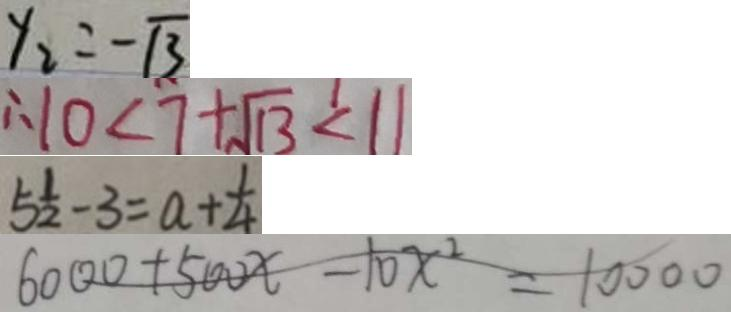Convert formula to latex. <formula><loc_0><loc_0><loc_500><loc_500>y _ { 2 } = - \sqrt { 3 } 
 \therefore 1 0 < 7 + \sqrt { 1 3 } < 1 1 
 5 \frac { 1 } { 2 } - 3 = a + \frac { 1 } { 4 } 
 6 0 0 0 + 5 0 0 x - 1 0 x ^ { 2 } = 1 0 0 0 0</formula> 